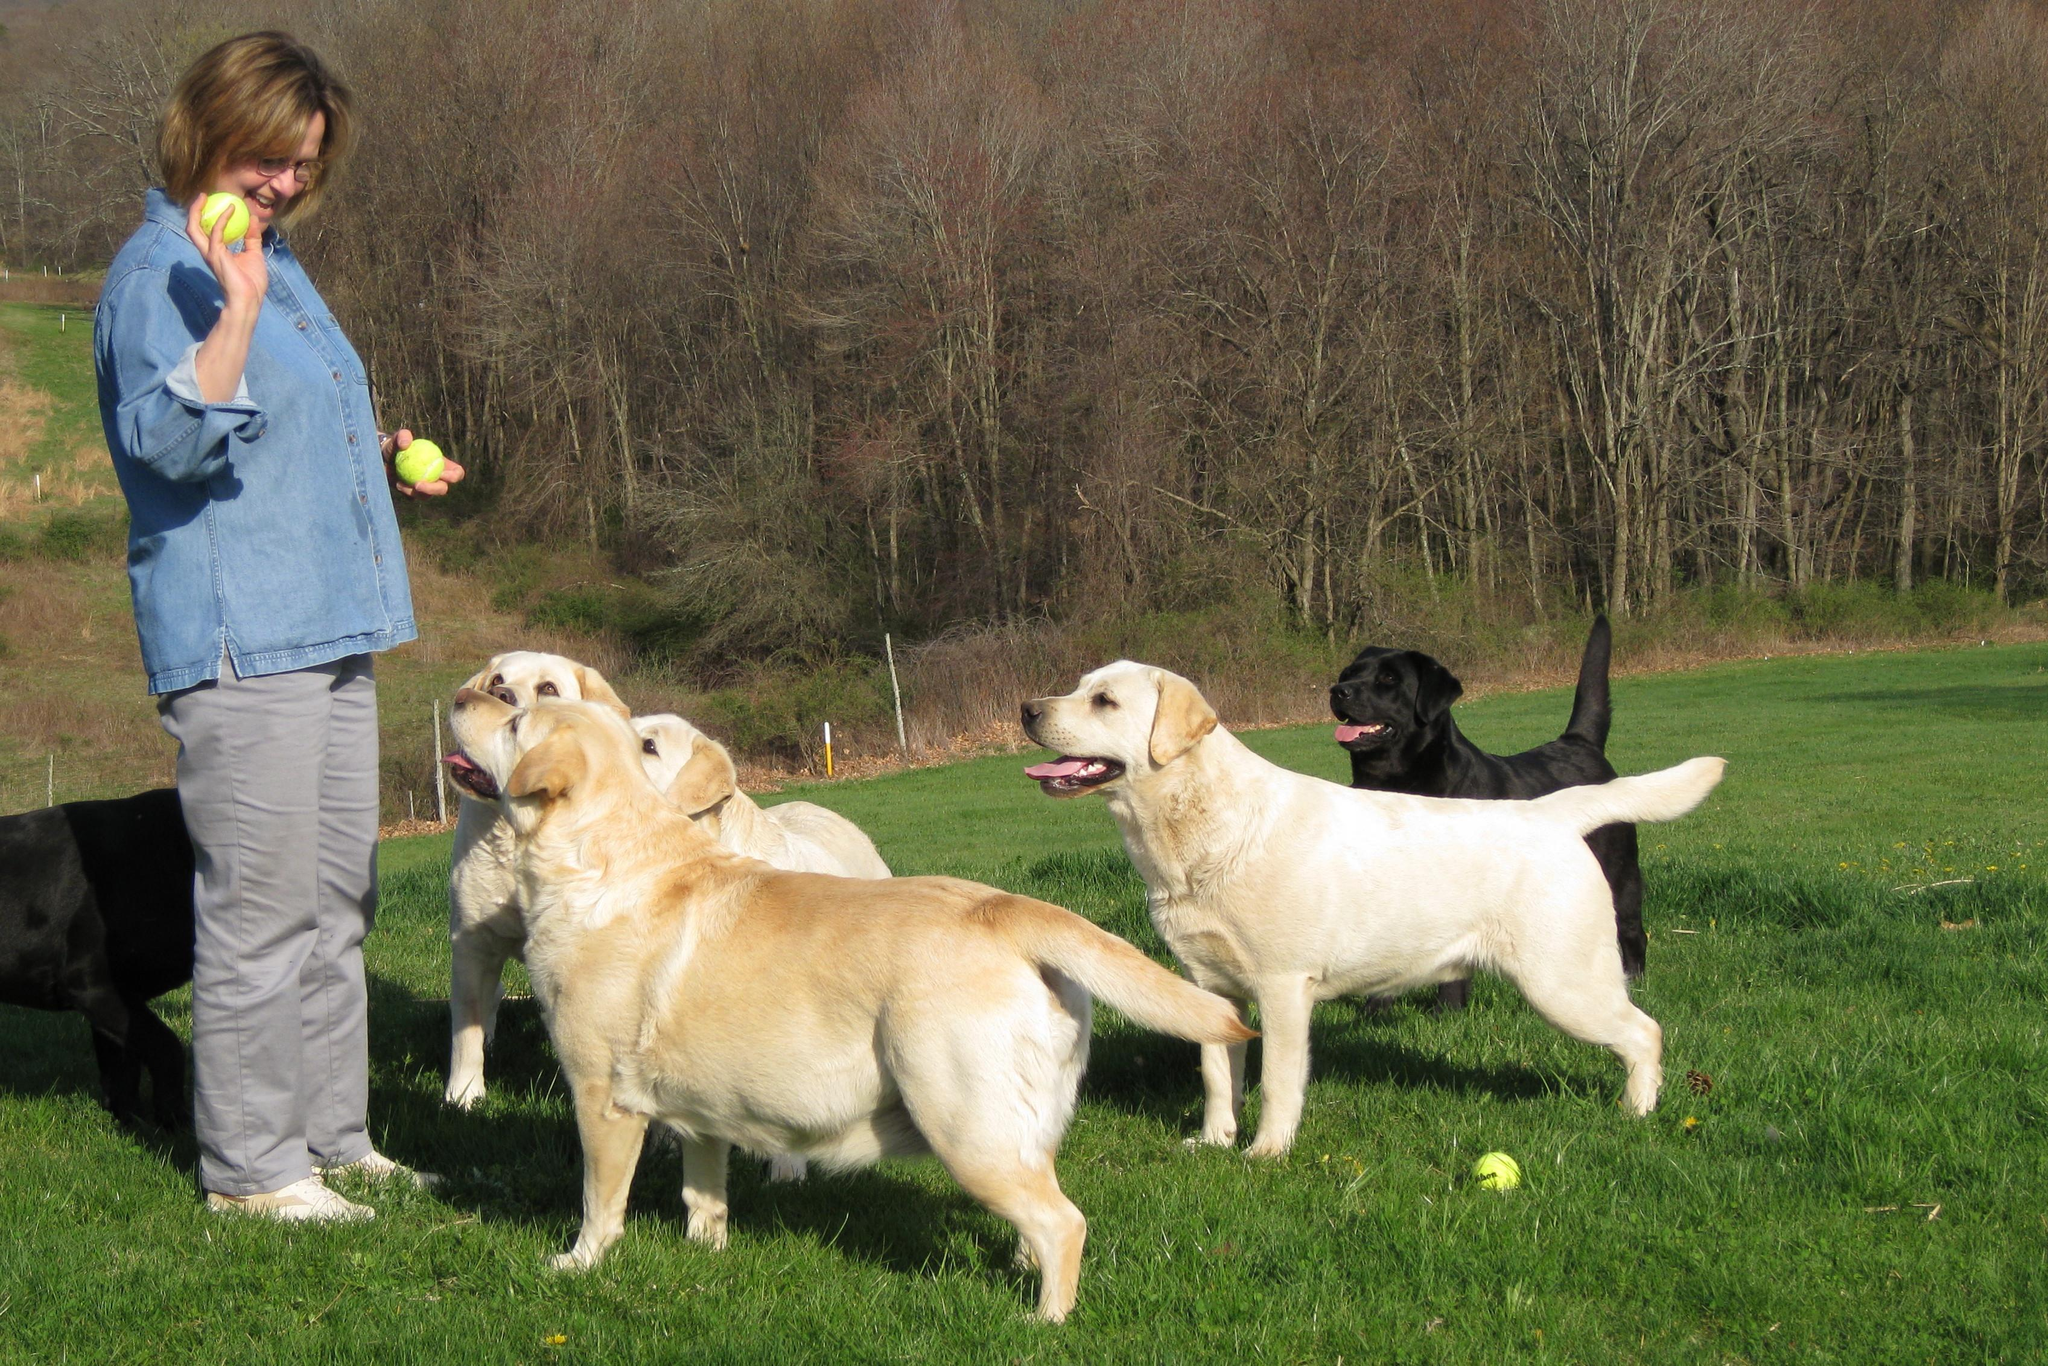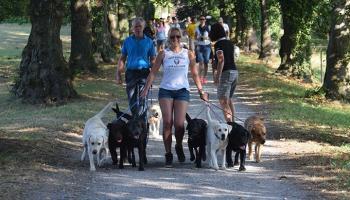The first image is the image on the left, the second image is the image on the right. Considering the images on both sides, is "One of the images includes dogs on the grass." valid? Answer yes or no. Yes. The first image is the image on the left, the second image is the image on the right. Analyze the images presented: Is the assertion "The image on the right shows a group of dogs that are all sitting or lying down, and all but one of the dogs are showing their tongues." valid? Answer yes or no. No. 